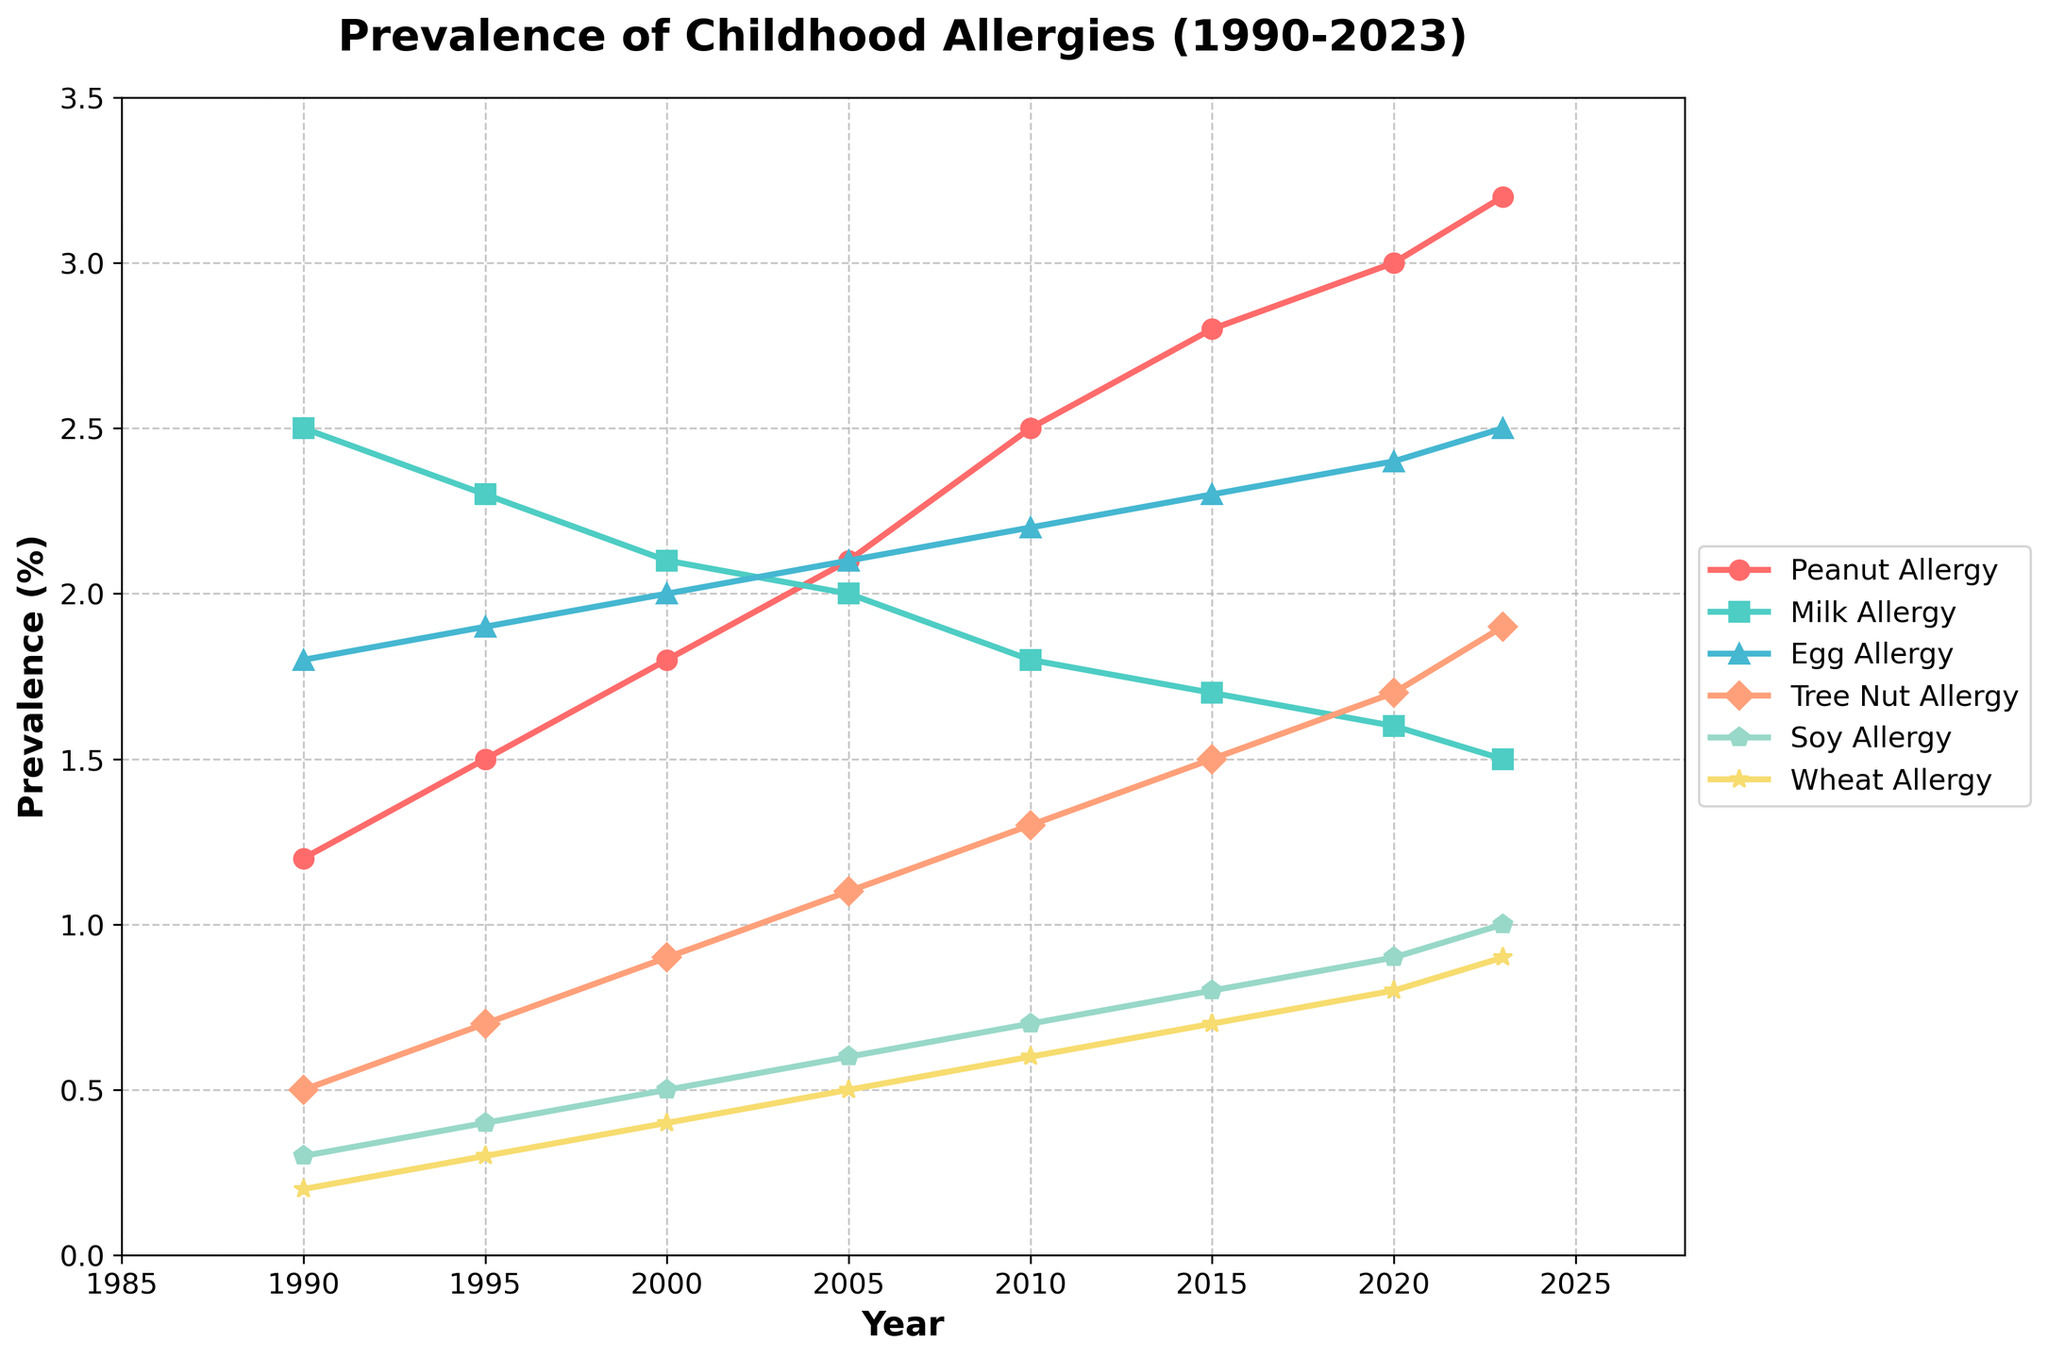What's the trend in peanut allergy prevalence from 1990 to 2023? The figure shows an increasing trend for peanut allergy prevalence, starting approximately at 1.2% in 1990 and rising consistently to about 3.2% by 2023.
Answer: Increasing Which type of allergy had the highest prevalence in 1990? By looking at the beginning of the lines on the y-axis, the Milk Allergy line starts at the highest position, indicating it had the highest prevalence in 1990.
Answer: Milk Allergy Between which years did egg allergy prevalence increase the most? Observing the slope of the Egg Allergy line, the steepest increase occurred from 2010 to 2015, where the prevalence jumped from approximately 2.2% to 2.3%.
Answer: 2010 to 2015 Which allergy had a decreasing trend in prevalence from 1990 to 2023? The lines that show a decreasing trend can be identified by a downward slope. The Milk Allergy line shows a decrease from about 2.5% in 1990 to 1.5% in 2023.
Answer: Milk Allergy What is the total increase in prevalence of tree nut allergy from 1990 to 2023? The prevalence of tree nut allergy increased from 0.5% in 1990 to 1.9% in 2023. The total increase is 1.9% - 0.5% = 1.4%.
Answer: 1.4% Which two allergies had the closest prevalence values in 2023? By observing the endpoint values for all lines in 2023, Soy Allergy and Wheat Allergy are closest with prevalences at approximately 1.0% and 0.9%, respectively.
Answer: Soy and Wheat Allergy Between Peanut and Wheat allergies, which had more rapid growth over the years? By comparing the slopes of Peanut and Wheat Allergy lines, Peanut Allergy shows a steeper climb from 1.2% to 3.2%, whereas Wheat Allergy gradually increased from 0.2% to 0.9%.
Answer: Peanut Allergy During which period did Soy Allergy show the most consistent increase? From the chart, Soy Allergy shows a consistent increase between 1990 to 2023 without major dips or spikes, showing the smoothest line among others.
Answer: 1990 to 2023 What is the combined prevalence of Egg and Tree Nut allergies in 2005? The prevalence of Egg Allergy in 2005 is 2.1% and Tree Nut Allergy is 1.1%. Combined prevalence is 2.1% + 1.1% = 3.2%.
Answer: 3.2% Which allergy showed the least change in prevalence from 1990 to 2023? The Wheat Allergy line shows the least change, starting from 0.2% in 1990 and rising only to 0.9% by 2023.
Answer: Wheat Allergy 